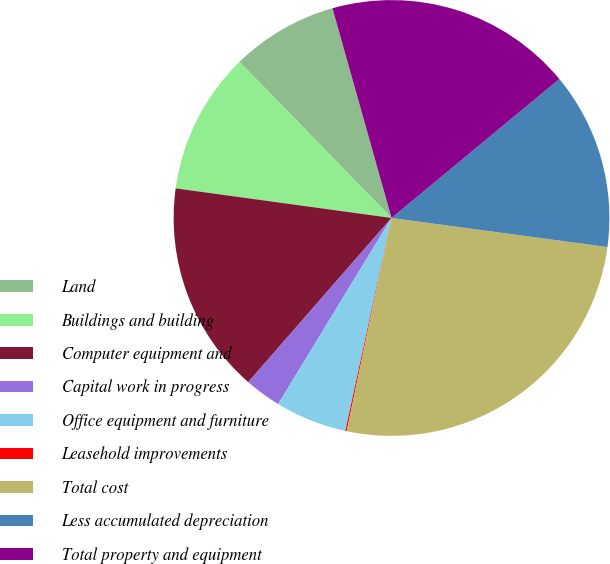<chart> <loc_0><loc_0><loc_500><loc_500><pie_chart><fcel>Land<fcel>Buildings and building<fcel>Computer equipment and<fcel>Capital work in progress<fcel>Office equipment and furniture<fcel>Leasehold improvements<fcel>Total cost<fcel>Less accumulated depreciation<fcel>Total property and equipment<nl><fcel>7.92%<fcel>10.54%<fcel>15.75%<fcel>2.71%<fcel>5.31%<fcel>0.1%<fcel>26.17%<fcel>13.14%<fcel>18.36%<nl></chart> 